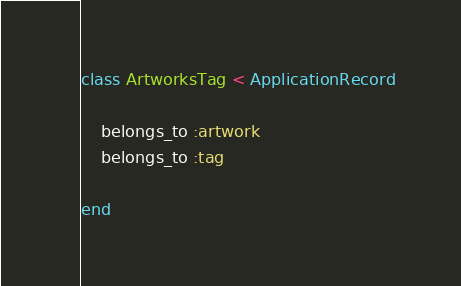Convert code to text. <code><loc_0><loc_0><loc_500><loc_500><_Ruby_>class ArtworksTag < ApplicationRecord

    belongs_to :artwork
    belongs_to :tag

end
</code> 